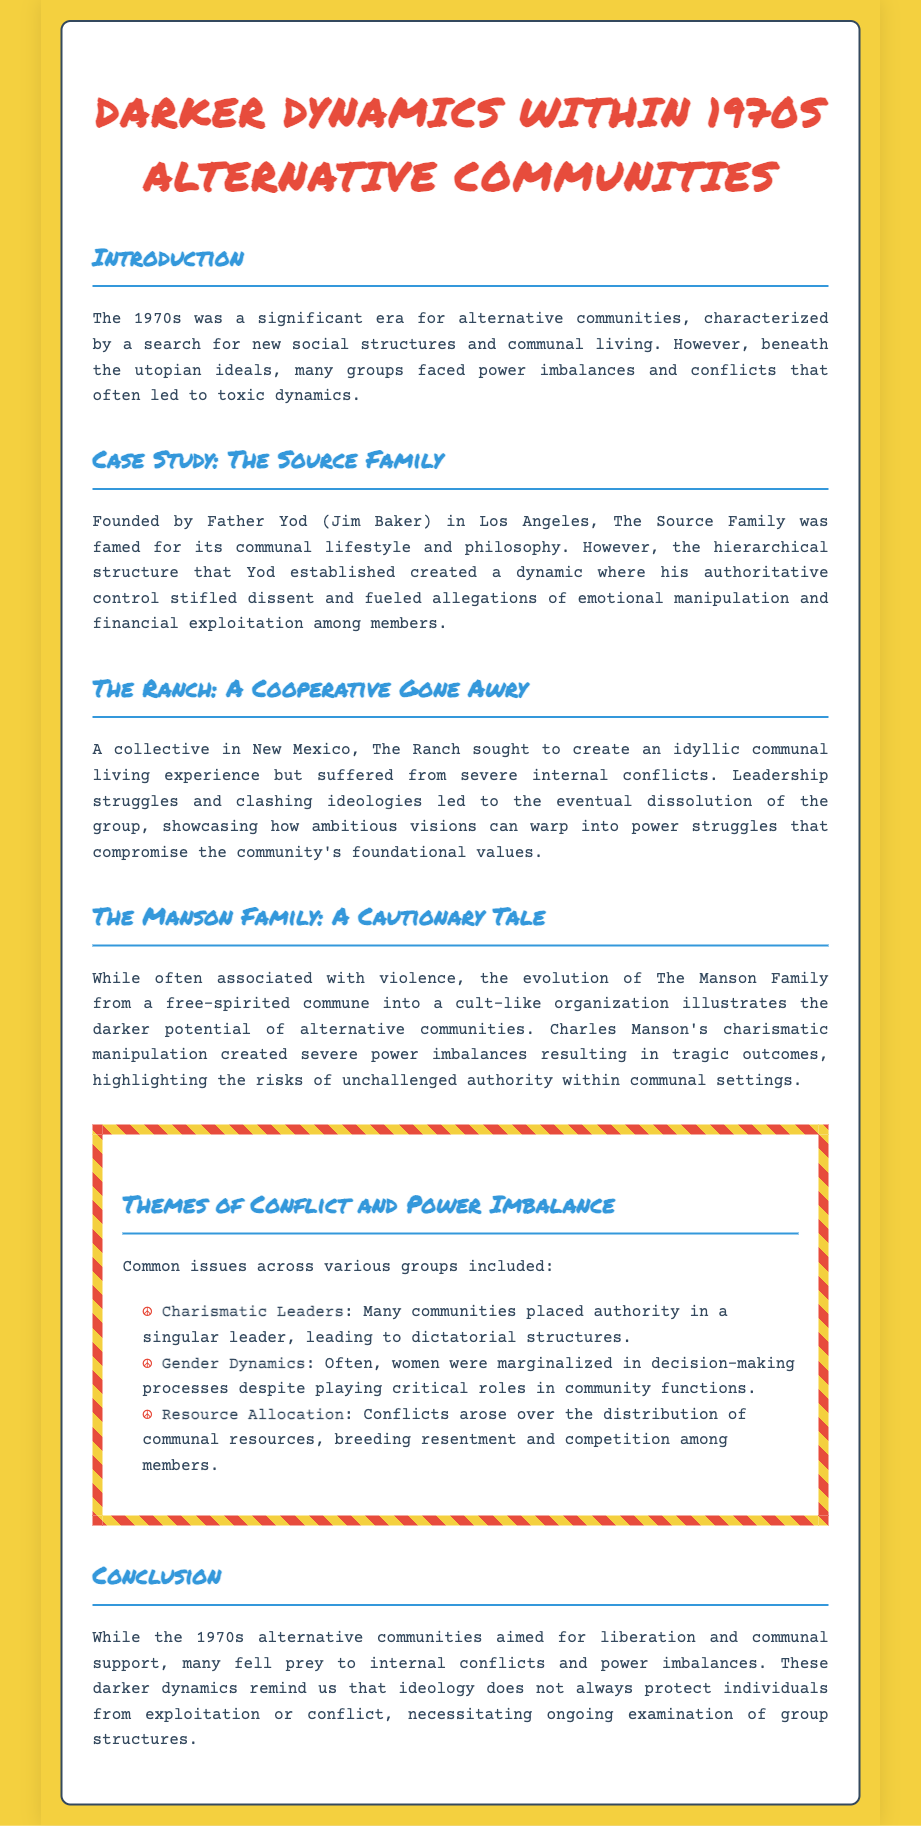What was the aim of the 1970s alternative communities? The memo states that the 1970s alternative communities aimed for liberation and communal support.
Answer: liberation and communal support Who founded The Source Family? The memo mentions Father Yod (Jim Baker) as the founder of The Source Family.
Answer: Father Yod (Jim Baker) What caused the dissolution of The Ranch? The document explains that leadership struggles and clashing ideologies led to the eventual dissolution of The Ranch.
Answer: leadership struggles and clashing ideologies What role did women often play in these communities? The memo indicates that women were often marginalized in decision-making processes despite playing critical roles in community functions.
Answer: marginalized Who led to severe power imbalances in The Manson Family? The document describes Charles Manson's charismatic manipulation as the cause of severe power imbalances in The Manson Family.
Answer: Charles Manson What is a common issue in various groups discussed in the memo? The memo lists several issues, among them are charismatic leaders and resource allocation conflicts.
Answer: charismatic leaders How does the document categorize the dynamics discussed? The memo identifies darker dynamics within certain alternative communities as the focus of the analysis.
Answer: darker dynamics What is the concluding message of the memo? The conclusion emphasizes that ideology does not always protect individuals from exploitation or conflict.
Answer: exploitation or conflict 